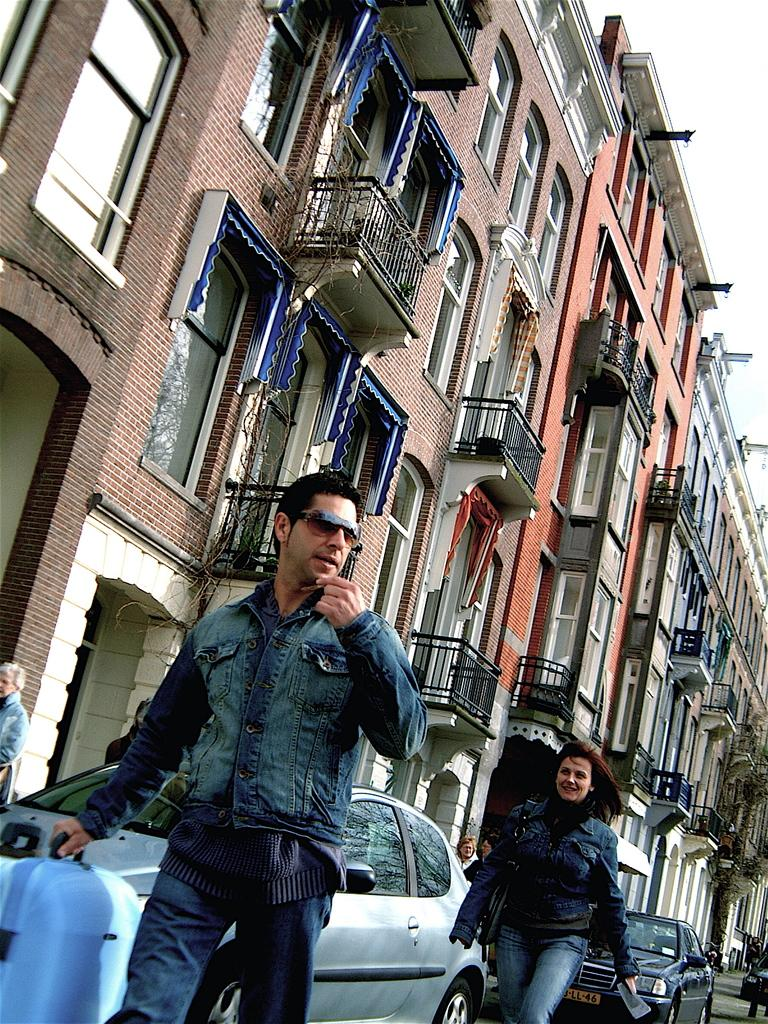What type of structures can be seen in the image? There are buildings in the image. What are the people in the image doing? There are people walking in the image. What mode of transportation is visible in the image? Cars are visible in the image. Can you describe the man in the image? There is a man holding a suitcase in the image. What type of vegetation can be seen in the image? There are plants in the image. Can you tell me how many snails are crawling on the plants in the image? There are no snails present in the image; only people, cars, and plants are visible. What type of lipstick is the man wearing in the image? There is no lipstick or indication of makeup in the image; the man is holding a suitcase. 